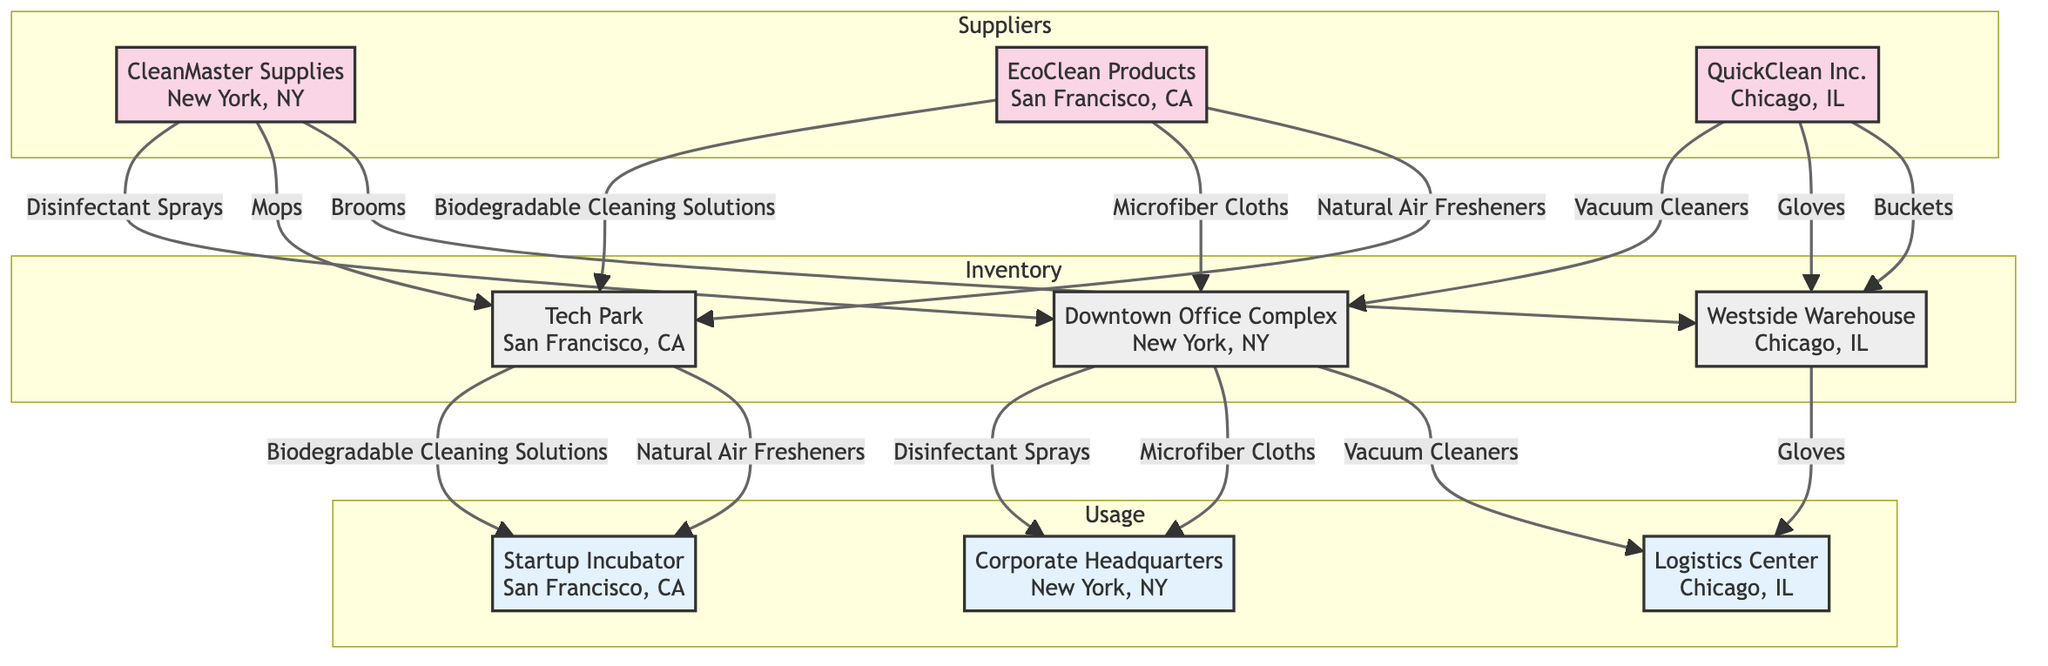What are the names of all suppliers in the diagram? The diagram includes three suppliers: CleanMaster Supplies, EcoClean Products, and QuickClean Inc. These are listed distinctly under the "Suppliers" section.
Answer: CleanMaster Supplies, EcoClean Products, QuickClean Inc Which inventory location is associated with "Disinfectant Sprays"? The "Disinfectant Sprays" item flows from CleanMaster Supplies to the Downtown Office Complex, indicating this is the related inventory location.
Answer: Downtown Office Complex How many items does QuickClean Inc. supply? QuickClean Inc. supplies four items: Vacuum Cleaners, Dust Pans, Gloves, and Buckets. This information is taken from the list under QuickClean Inc. in the diagram.
Answer: Four From which inventory location can items be used at the Corporate Headquarters? The Downtown Office Complex supplies Disinfectant Sprays and Microfiber Cloths to the Corporate Headquarters, making it the only inventory location that supports this usage location.
Answer: Downtown Office Complex What is the relationship between EcoClean Products and Tech Park? EcoClean Products supplies Biodegradable Cleaning Solutions and Natural Air Fresheners to Tech Park, showing a direct connection between them in the network.
Answer: Supplies How many items are provided by CleanMaster Supplies that are located at any usage location? CleanMaster Supplies provides two items, Disinfectant Sprays and Microfiber Cloths, which are used at the Corporate Headquarters, thus answering the question by counting the applicable items at usage locations.
Answer: Two Which usage location receives Biodegradable Cleaning Solutions? The Startup Incubator receives Biodegradable Cleaning Solutions from Tech Park; this connection is established by following the arrows in the diagram.
Answer: Startup Incubator What is the total number of usage locations in the diagram? There are three usage locations: Corporate Headquarters, Startup Incubator, and Logistics Center, all listed in the "Usage" section of the diagram.
Answer: Three Which item is used at both the Downtown Office Complex and the Corporate Headquarters? The item Microfiber Cloths is shared between the Downtown Office Complex (inventory) and the Corporate Headquarters (usage), as indicated by the arrows connecting the two.
Answer: Microfiber Cloths 